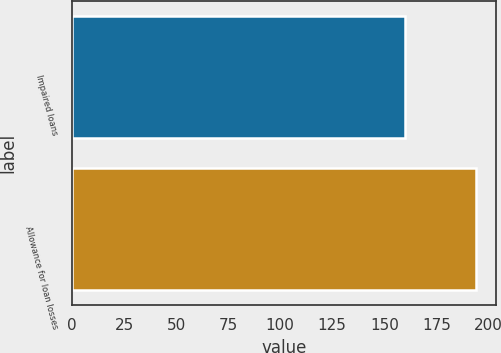<chart> <loc_0><loc_0><loc_500><loc_500><bar_chart><fcel>Impaired loans<fcel>Allowance for loan losses<nl><fcel>160<fcel>194<nl></chart> 